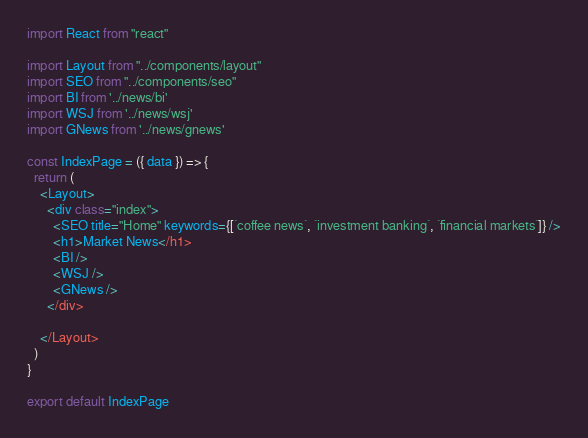Convert code to text. <code><loc_0><loc_0><loc_500><loc_500><_JavaScript_>import React from "react"

import Layout from "../components/layout"
import SEO from "../components/seo"
import BI from '../news/bi'
import WSJ from '../news/wsj'
import GNews from '../news/gnews'

const IndexPage = ({ data }) => {
  return (
    <Layout>
      <div class="index">
        <SEO title="Home" keywords={[`coffee news`, `investment banking`, `financial markets`]} />
        <h1>Market News</h1>
        <BI />
        <WSJ />
        <GNews />
      </div>

    </Layout>
  )
}

export default IndexPage</code> 